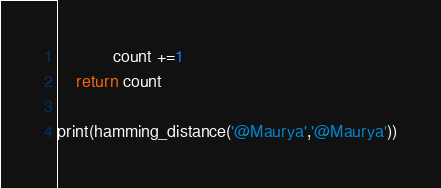Convert code to text. <code><loc_0><loc_0><loc_500><loc_500><_Python_>            count +=1
    return count

print(hamming_distance('@Maurya','@Maurya'))

</code> 